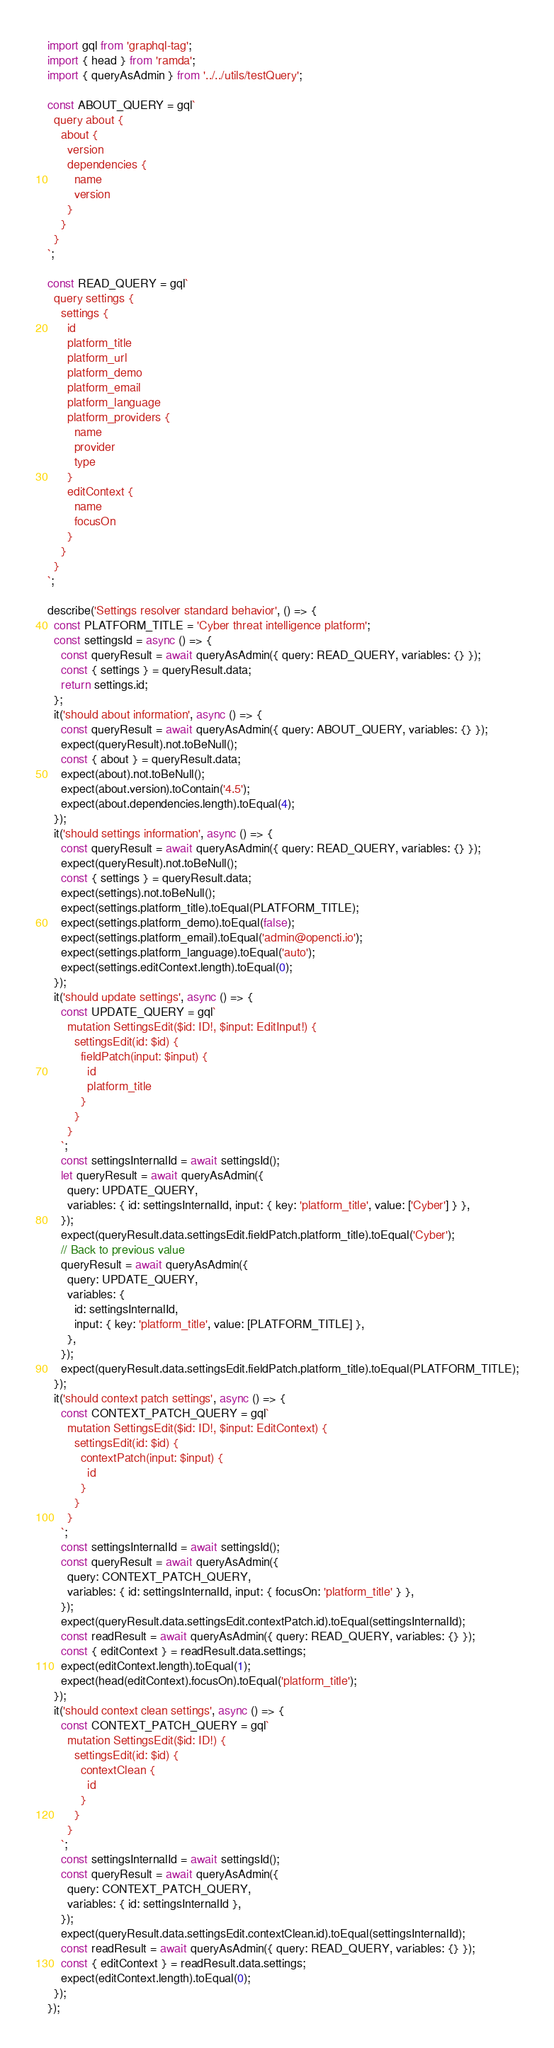Convert code to text. <code><loc_0><loc_0><loc_500><loc_500><_JavaScript_>import gql from 'graphql-tag';
import { head } from 'ramda';
import { queryAsAdmin } from '../../utils/testQuery';

const ABOUT_QUERY = gql`
  query about {
    about {
      version
      dependencies {
        name
        version
      }
    }
  }
`;

const READ_QUERY = gql`
  query settings {
    settings {
      id
      platform_title
      platform_url
      platform_demo
      platform_email
      platform_language
      platform_providers {
        name
        provider
        type
      }
      editContext {
        name
        focusOn
      }
    }
  }
`;

describe('Settings resolver standard behavior', () => {
  const PLATFORM_TITLE = 'Cyber threat intelligence platform';
  const settingsId = async () => {
    const queryResult = await queryAsAdmin({ query: READ_QUERY, variables: {} });
    const { settings } = queryResult.data;
    return settings.id;
  };
  it('should about information', async () => {
    const queryResult = await queryAsAdmin({ query: ABOUT_QUERY, variables: {} });
    expect(queryResult).not.toBeNull();
    const { about } = queryResult.data;
    expect(about).not.toBeNull();
    expect(about.version).toContain('4.5');
    expect(about.dependencies.length).toEqual(4);
  });
  it('should settings information', async () => {
    const queryResult = await queryAsAdmin({ query: READ_QUERY, variables: {} });
    expect(queryResult).not.toBeNull();
    const { settings } = queryResult.data;
    expect(settings).not.toBeNull();
    expect(settings.platform_title).toEqual(PLATFORM_TITLE);
    expect(settings.platform_demo).toEqual(false);
    expect(settings.platform_email).toEqual('admin@opencti.io');
    expect(settings.platform_language).toEqual('auto');
    expect(settings.editContext.length).toEqual(0);
  });
  it('should update settings', async () => {
    const UPDATE_QUERY = gql`
      mutation SettingsEdit($id: ID!, $input: EditInput!) {
        settingsEdit(id: $id) {
          fieldPatch(input: $input) {
            id
            platform_title
          }
        }
      }
    `;
    const settingsInternalId = await settingsId();
    let queryResult = await queryAsAdmin({
      query: UPDATE_QUERY,
      variables: { id: settingsInternalId, input: { key: 'platform_title', value: ['Cyber'] } },
    });
    expect(queryResult.data.settingsEdit.fieldPatch.platform_title).toEqual('Cyber');
    // Back to previous value
    queryResult = await queryAsAdmin({
      query: UPDATE_QUERY,
      variables: {
        id: settingsInternalId,
        input: { key: 'platform_title', value: [PLATFORM_TITLE] },
      },
    });
    expect(queryResult.data.settingsEdit.fieldPatch.platform_title).toEqual(PLATFORM_TITLE);
  });
  it('should context patch settings', async () => {
    const CONTEXT_PATCH_QUERY = gql`
      mutation SettingsEdit($id: ID!, $input: EditContext) {
        settingsEdit(id: $id) {
          contextPatch(input: $input) {
            id
          }
        }
      }
    `;
    const settingsInternalId = await settingsId();
    const queryResult = await queryAsAdmin({
      query: CONTEXT_PATCH_QUERY,
      variables: { id: settingsInternalId, input: { focusOn: 'platform_title' } },
    });
    expect(queryResult.data.settingsEdit.contextPatch.id).toEqual(settingsInternalId);
    const readResult = await queryAsAdmin({ query: READ_QUERY, variables: {} });
    const { editContext } = readResult.data.settings;
    expect(editContext.length).toEqual(1);
    expect(head(editContext).focusOn).toEqual('platform_title');
  });
  it('should context clean settings', async () => {
    const CONTEXT_PATCH_QUERY = gql`
      mutation SettingsEdit($id: ID!) {
        settingsEdit(id: $id) {
          contextClean {
            id
          }
        }
      }
    `;
    const settingsInternalId = await settingsId();
    const queryResult = await queryAsAdmin({
      query: CONTEXT_PATCH_QUERY,
      variables: { id: settingsInternalId },
    });
    expect(queryResult.data.settingsEdit.contextClean.id).toEqual(settingsInternalId);
    const readResult = await queryAsAdmin({ query: READ_QUERY, variables: {} });
    const { editContext } = readResult.data.settings;
    expect(editContext.length).toEqual(0);
  });
});
</code> 